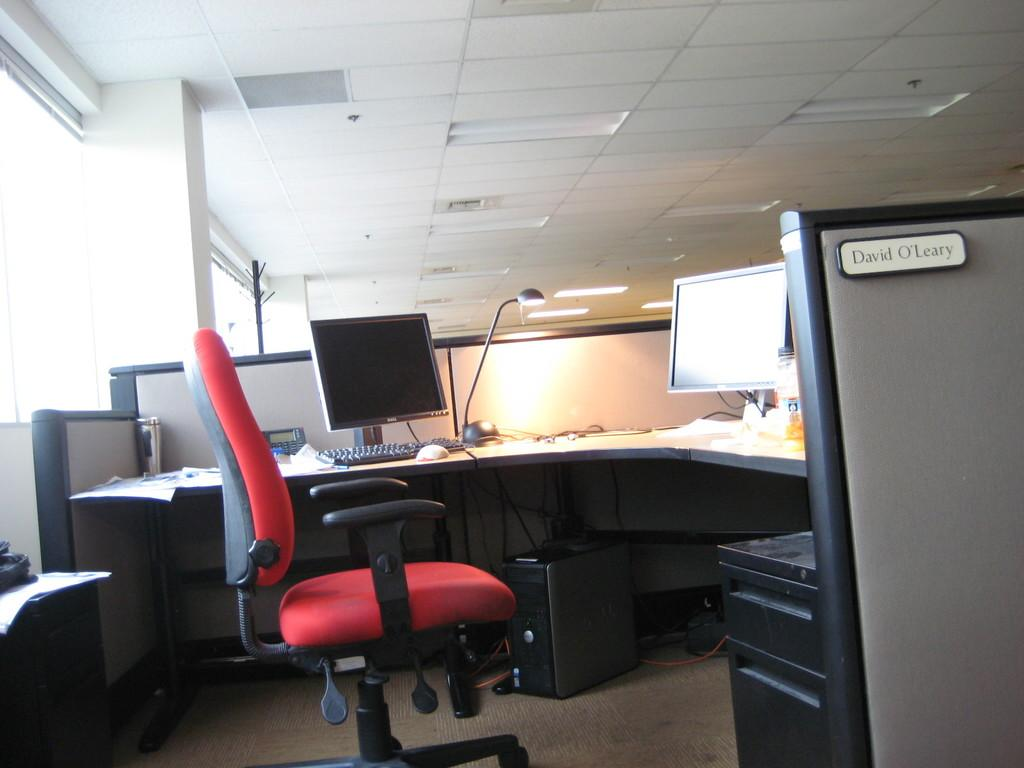<image>
Describe the image concisely. The cubicle of David O'Leary is shown, with a red chair and two computer monitors. 